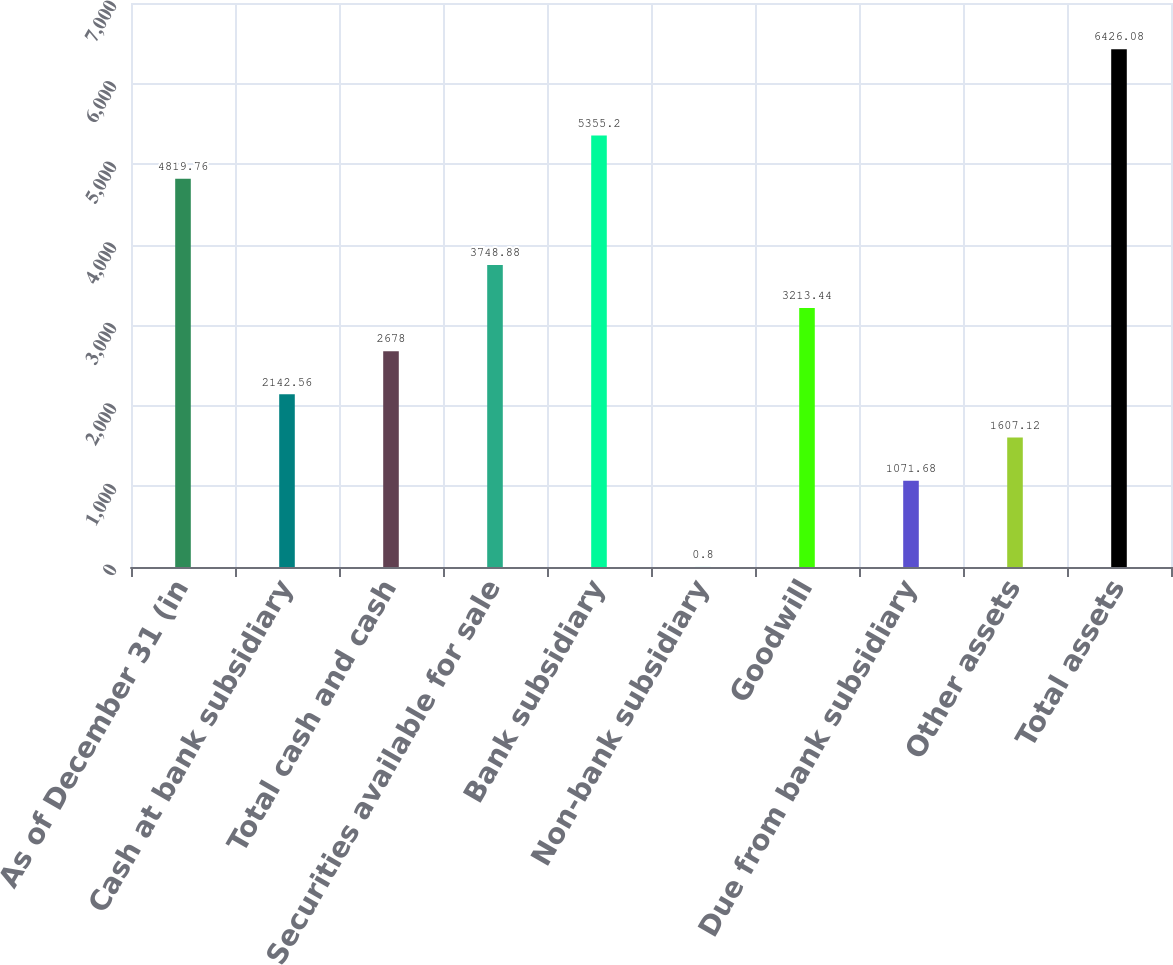<chart> <loc_0><loc_0><loc_500><loc_500><bar_chart><fcel>As of December 31 (in<fcel>Cash at bank subsidiary<fcel>Total cash and cash<fcel>Securities available for sale<fcel>Bank subsidiary<fcel>Non-bank subsidiary<fcel>Goodwill<fcel>Due from bank subsidiary<fcel>Other assets<fcel>Total assets<nl><fcel>4819.76<fcel>2142.56<fcel>2678<fcel>3748.88<fcel>5355.2<fcel>0.8<fcel>3213.44<fcel>1071.68<fcel>1607.12<fcel>6426.08<nl></chart> 